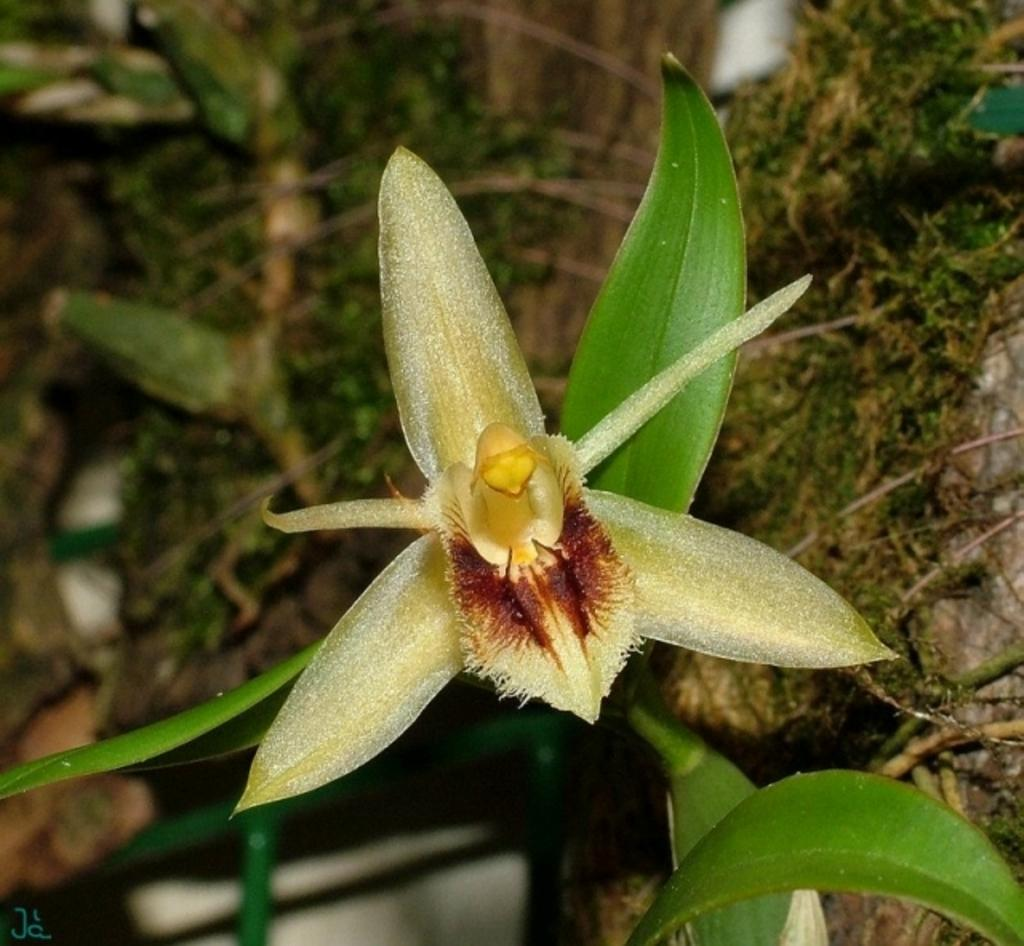What is located in the foreground of the image? There is a flower and a plant in the foreground of the image. Can you describe the plants in the foreground? The flower and plant are both located in the foreground of the image. What can be seen in the background of the image? There are plants visible in the background of the image. What type of protest is taking place in the image? There is no protest present in the image; it features a flower, a plant, and other plants in the background. What type of sticks can be seen in the image? There are no sticks present in the image. 